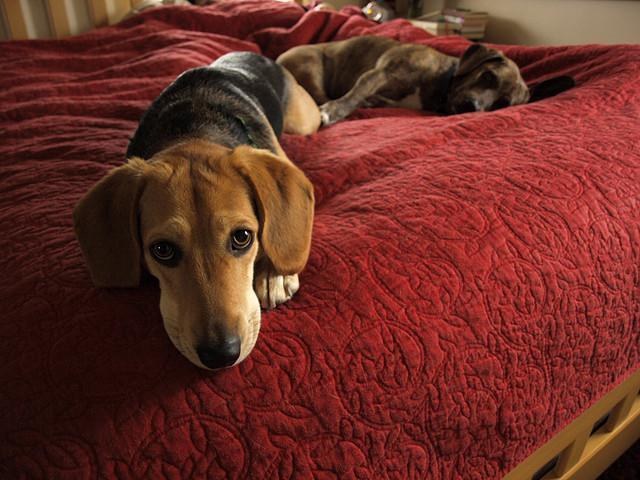How many dogs are on this bed?
Give a very brief answer. 2. How many of the dogs are awake?
Give a very brief answer. 1. How many dogs are in the photo?
Give a very brief answer. 2. 